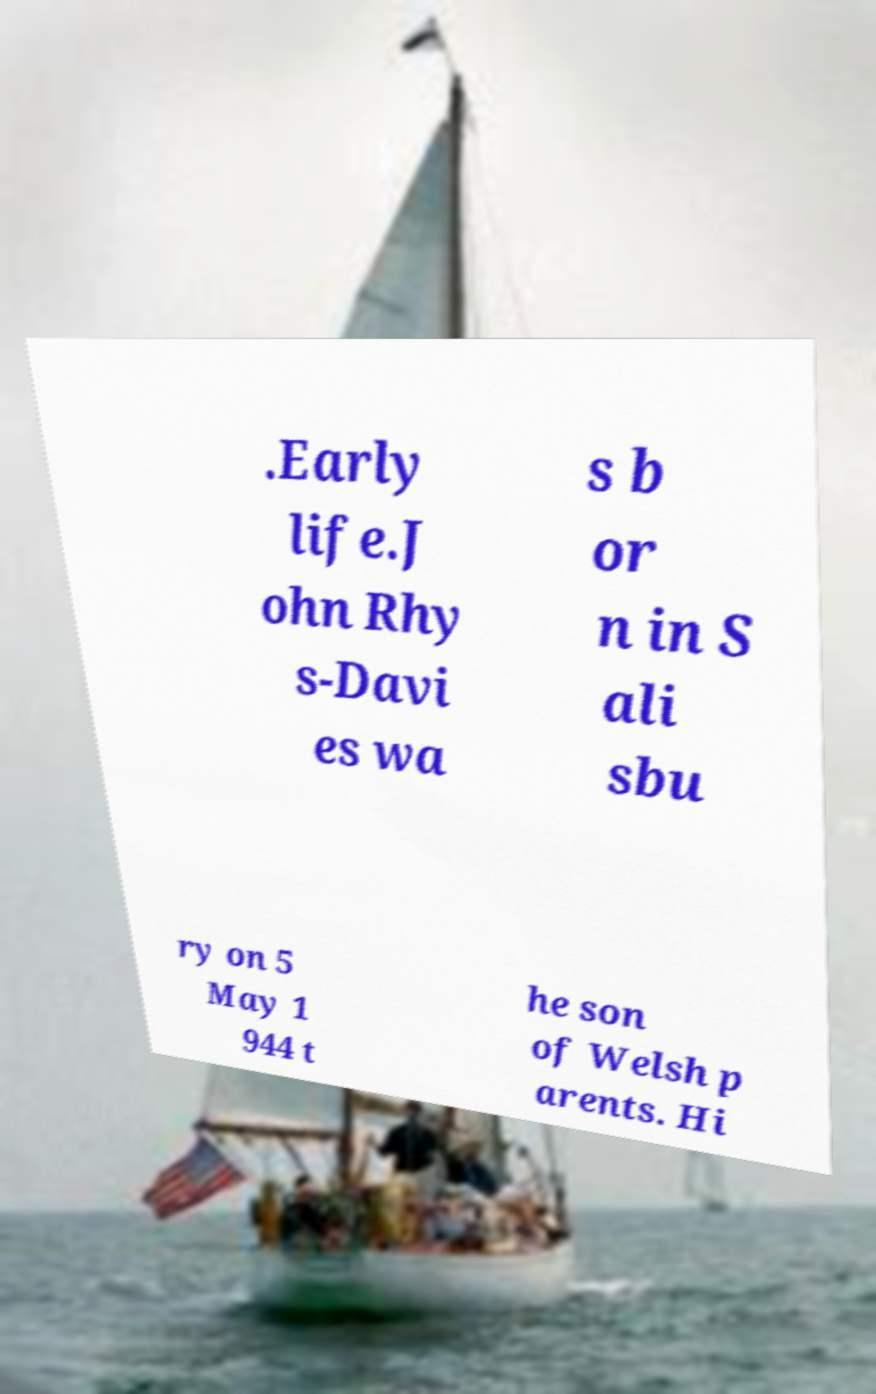Please read and relay the text visible in this image. What does it say? .Early life.J ohn Rhy s-Davi es wa s b or n in S ali sbu ry on 5 May 1 944 t he son of Welsh p arents. Hi 